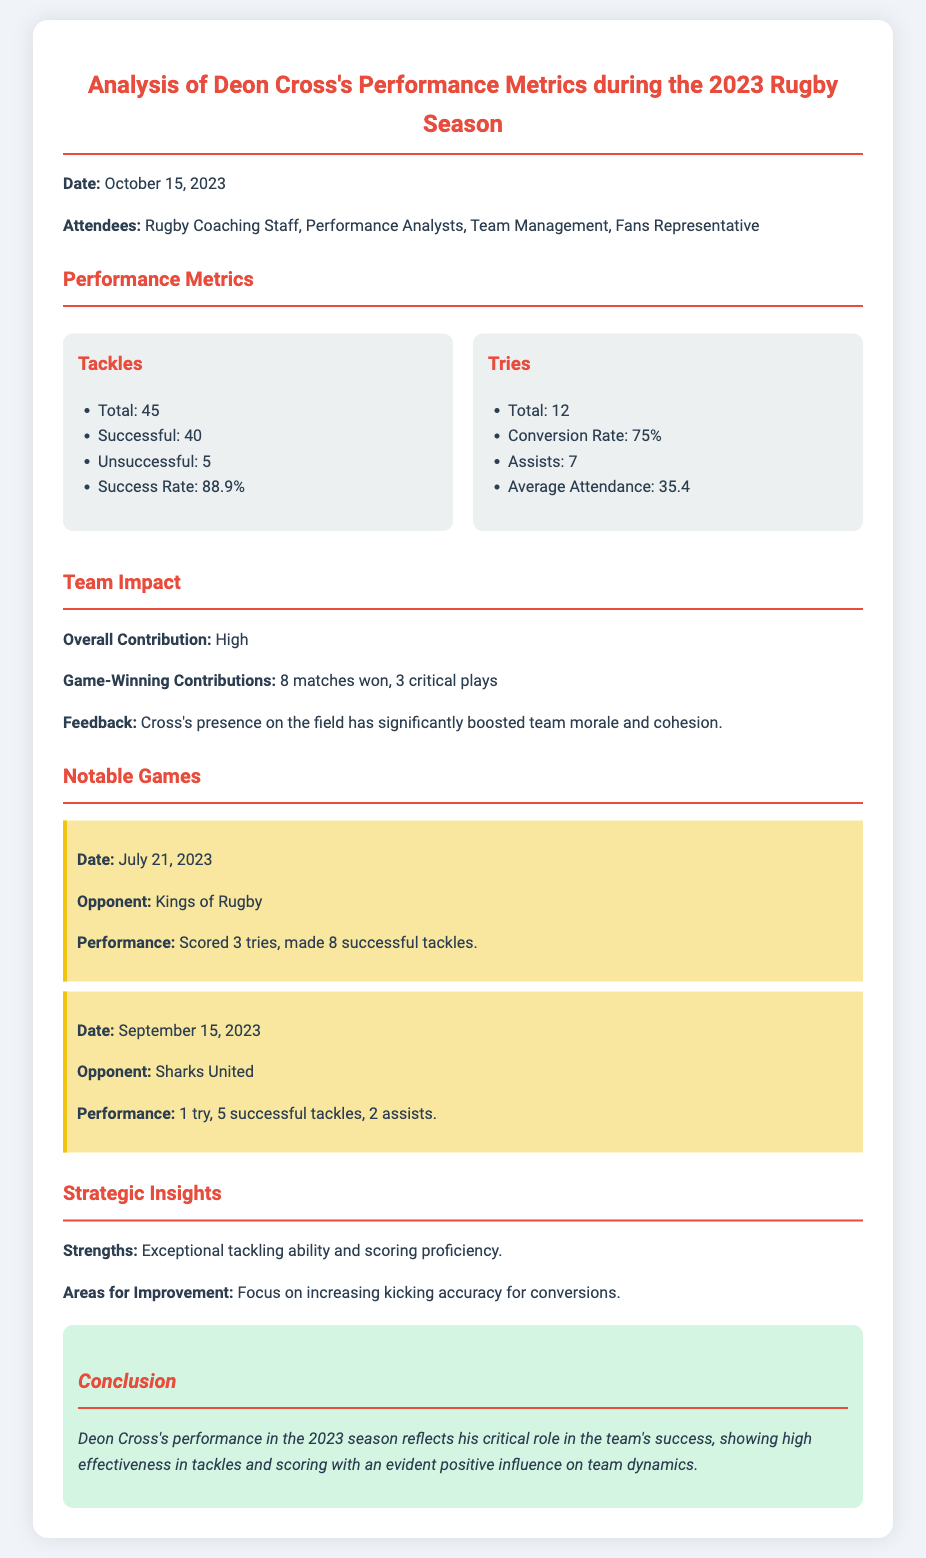What is Deon Cross's total number of tackles? The document states that Deon Cross made 45 tackles during the season.
Answer: 45 What was Deon Cross's successful tackle rate? The success rate for Deon Cross's tackles is given as 88.9%.
Answer: 88.9% How many tries did Deon Cross score in the 2023 season? According to the document, Deon Cross scored a total of 12 tries.
Answer: 12 On what date did Deon Cross score 3 tries? The notable game against Kings of Rugby, where he scored 3 tries, took place on July 21, 2023.
Answer: July 21, 2023 How many game-winning contributions did he have? The analysis mentions that he contributed to 8 matches won with 3 critical plays.
Answer: 8 matches won, 3 critical plays What is stated as an area for improvement for Deon Cross? The document suggests that he should focus on increasing his kicking accuracy for conversions.
Answer: Kicking accuracy for conversions What is the overall contribution rating of Deon Cross in the team? The overall contribution of Deon Cross is rated as "High" in the document.
Answer: High What feedback is mentioned regarding Deon Cross's presence on the field? Feedback indicates that his presence significantly boosted team morale and cohesion.
Answer: Boosted team morale and cohesion 